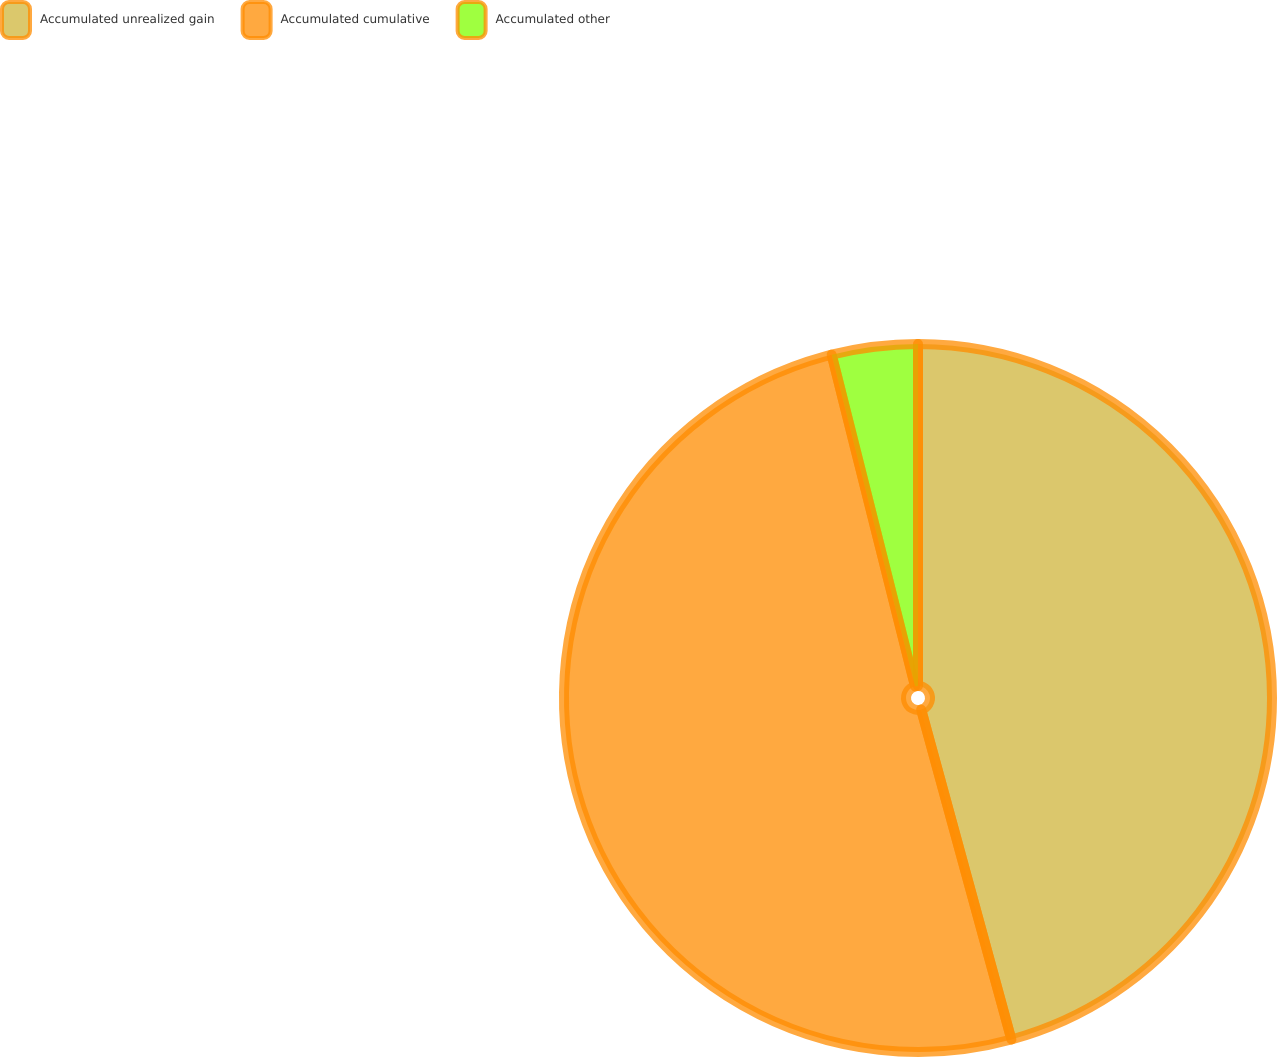Convert chart. <chart><loc_0><loc_0><loc_500><loc_500><pie_chart><fcel>Accumulated unrealized gain<fcel>Accumulated cumulative<fcel>Accumulated other<nl><fcel>45.75%<fcel>50.33%<fcel>3.92%<nl></chart> 